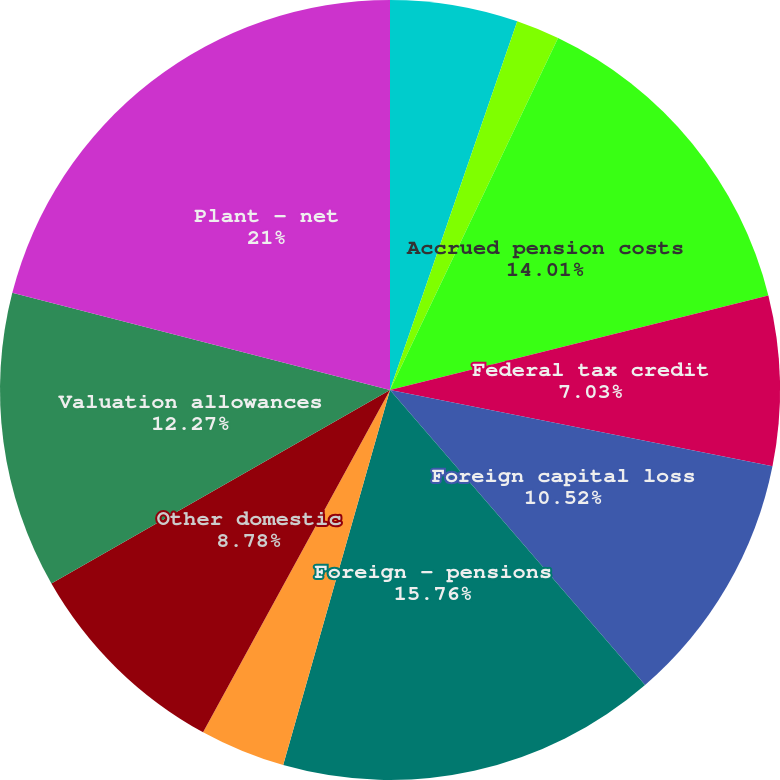Convert chart to OTSL. <chart><loc_0><loc_0><loc_500><loc_500><pie_chart><fcel>Deferred investment tax<fcel>NUG contracts and buybacks<fcel>Accrued pension costs<fcel>Federal tax credit<fcel>Foreign capital loss<fcel>Foreign - pensions<fcel>Foreign - other<fcel>Other domestic<fcel>Valuation allowances<fcel>Plant - net<nl><fcel>5.29%<fcel>1.8%<fcel>14.01%<fcel>7.03%<fcel>10.52%<fcel>15.76%<fcel>3.54%<fcel>8.78%<fcel>12.27%<fcel>20.99%<nl></chart> 